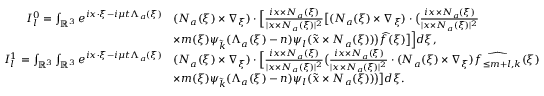<formula> <loc_0><loc_0><loc_500><loc_500>\begin{array} { r l } { I _ { l } ^ { 0 } = \int _ { \mathbb { R } ^ { 3 } } e ^ { i x \cdot \xi - i \mu t \Lambda _ { a } ( \xi ) } } & { ( N _ { a } ( \xi ) \times \nabla _ { \xi } ) \cdot \left [ \frac { i x \times N _ { a } ( \xi ) } { | x \times N _ { a } ( \xi ) | ^ { 2 } } \left [ ( N _ { a } ( \xi ) \times \nabla _ { \xi } ) \cdot \left ( \frac { i x \times N _ { a } ( \xi ) } { | x \times N _ { a } ( \xi ) | ^ { 2 } } } \\ & { \times m ( \xi ) \psi _ { \tilde { k } } ( \Lambda _ { a } ( \xi ) - n ) \psi _ { l } ( \tilde { x } \times N _ { a } ( \xi ) ) \right ) \widehat { f } ( \xi ) \right ] \right ] d \xi , } \\ { I _ { l } ^ { 1 } = \int _ { \mathbb { R } ^ { 3 } } \int _ { \mathbb { R } ^ { 3 } } e ^ { i x \cdot \xi - i \mu t \Lambda _ { a } ( \xi ) } } & { ( N _ { a } ( \xi ) \times \nabla _ { \xi } ) \cdot \left [ \frac { i x \times N _ { a } ( \xi ) } { | x \times N _ { a } ( \xi ) | ^ { 2 } } \left ( \frac { i x \times N _ { a } ( \xi ) } { | x \times N _ { a } ( \xi ) | ^ { 2 } } \cdot ( N _ { a } ( \xi ) \times \nabla _ { \xi } ) \widehat { f _ { \leq m + l , k } } ( \xi ) } \\ & { \times m ( \xi ) \psi _ { \tilde { k } } ( \Lambda _ { a } ( \xi ) - n ) \psi _ { l } ( \tilde { x } \times N _ { a } ( \xi ) ) \right ) \right ] d \xi . } \end{array}</formula> 